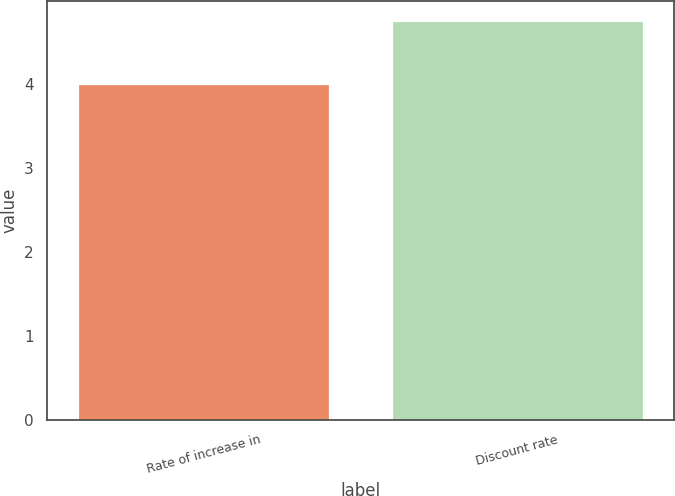<chart> <loc_0><loc_0><loc_500><loc_500><bar_chart><fcel>Rate of increase in<fcel>Discount rate<nl><fcel>4<fcel>4.75<nl></chart> 